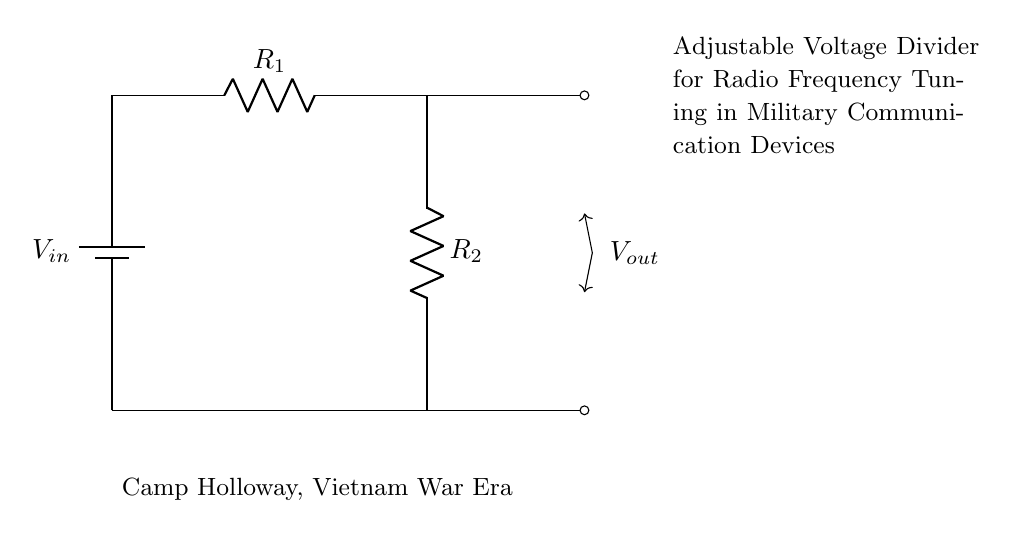What are the components of this circuit? The circuit consists of two resistors and a battery. The resistors are labeled R1 and R2, and the battery is labeled Vin.
Answer: R1, R2, battery What is the function of the resistors in this circuit? The resistors in a voltage divider are used to divide the input voltage into a lower output voltage. R1 and R2 determine the proportion of voltage that appears across R2, which is Vout.
Answer: Voltage division What is the output voltage referred to in the circuit? The output voltage (Vout) is the voltage measured across resistor R2. The circuit diagram indicates that this is the designated output voltage for adjustments.
Answer: Vout How does the output voltage change with the values of R1 and R2? The output voltage (Vout) varies according to the resistances of R1 and R2 based on the formula Vout = Vin * (R2 / (R1 + R2)). Increasing R2 relative to R1 will increase Vout and vice versa.
Answer: Proportional relationship What is the significance of the label "Adjustable Voltage Divider for Radio Frequency Tuning"? This label signifies that the voltage divider can be adjusted to provide a specific output voltage tailored for tuning radio frequencies in military communication devices, which is crucial for proper signal transmission and reception.
Answer: Tuning purpose What is the connection between the battery and the resistors? The battery is connected to the first resistor (R1), establishing the input voltage for the voltage divider circuit. R1 then connects to R2, completing the circuit for current to flow.
Answer: Series connection Where is this circuit diagram indicated to be used? The circuit diagram indicates it is used in Camp Holloway during the Vietnam War era, suggesting historical significance in military communications.
Answer: Camp Holloway, Vietnam War 